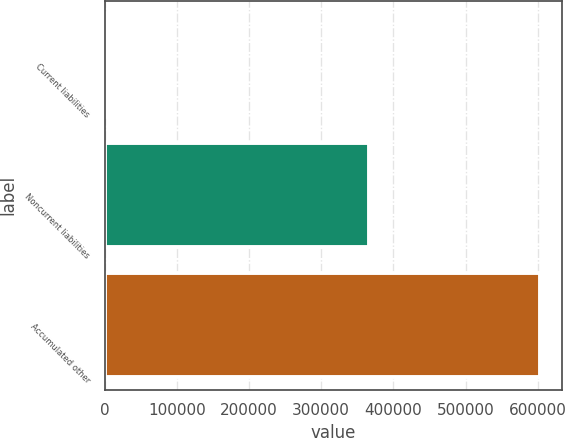Convert chart to OTSL. <chart><loc_0><loc_0><loc_500><loc_500><bar_chart><fcel>Current liabilities<fcel>Noncurrent liabilities<fcel>Accumulated other<nl><fcel>3605<fcel>366822<fcel>603610<nl></chart> 